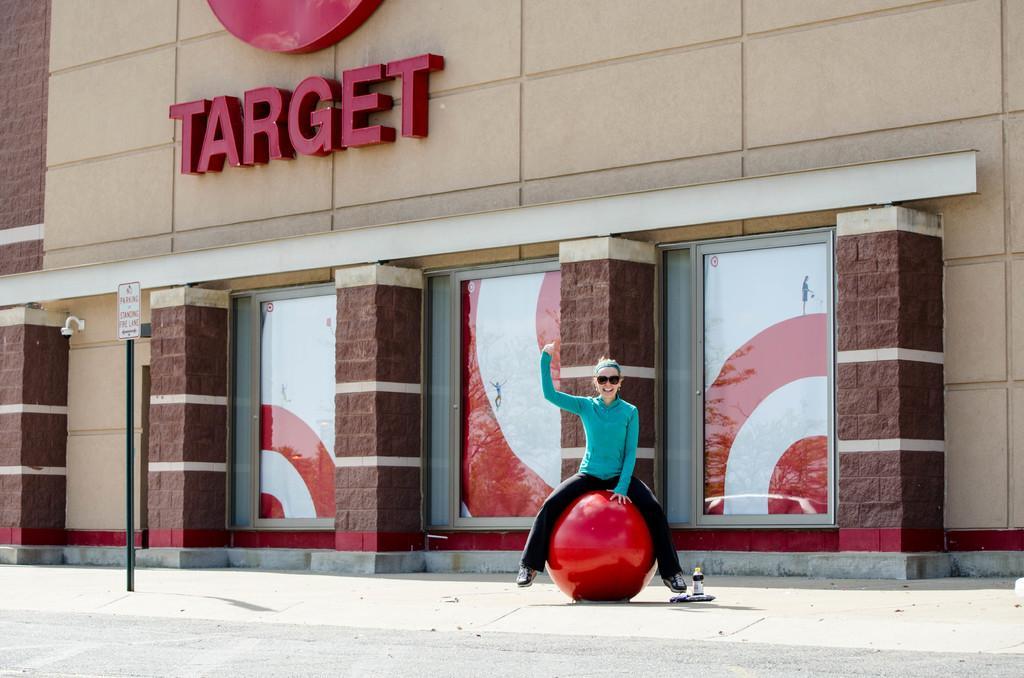Could you give a brief overview of what you see in this image? In the center of the image we can see a woman sitting on a ball. On the backside see a building with doors, lights and a signboard. We can also see a pole with a board and a bottle on the ground. 